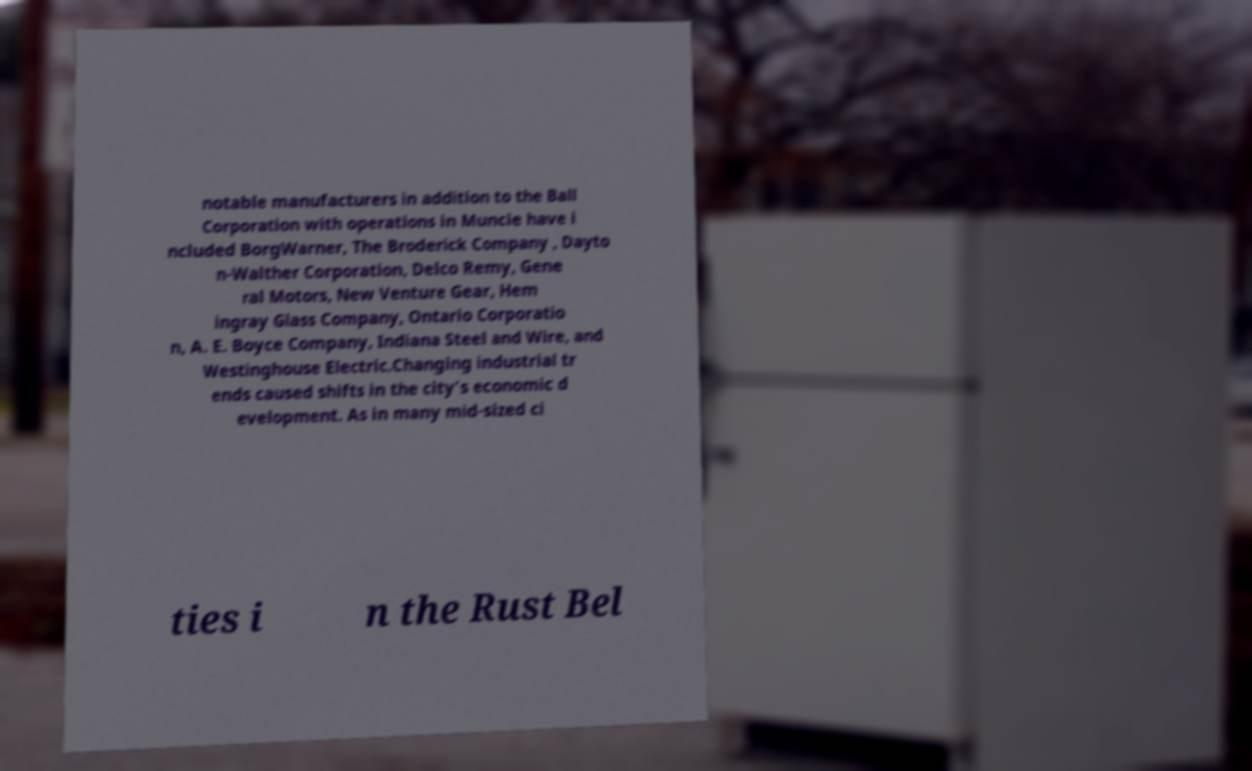Can you read and provide the text displayed in the image?This photo seems to have some interesting text. Can you extract and type it out for me? notable manufacturers in addition to the Ball Corporation with operations in Muncie have i ncluded BorgWarner, The Broderick Company , Dayto n-Walther Corporation, Delco Remy, Gene ral Motors, New Venture Gear, Hem ingray Glass Company, Ontario Corporatio n, A. E. Boyce Company, Indiana Steel and Wire, and Westinghouse Electric.Changing industrial tr ends caused shifts in the city's economic d evelopment. As in many mid-sized ci ties i n the Rust Bel 